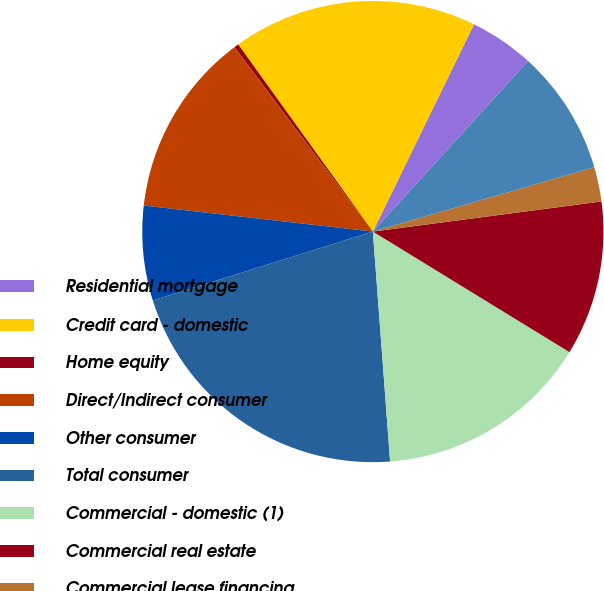Convert chart. <chart><loc_0><loc_0><loc_500><loc_500><pie_chart><fcel>Residential mortgage<fcel>Credit card - domestic<fcel>Home equity<fcel>Direct/Indirect consumer<fcel>Other consumer<fcel>Total consumer<fcel>Commercial - domestic (1)<fcel>Commercial real estate<fcel>Commercial lease financing<fcel>Commercial - foreign<nl><fcel>4.53%<fcel>17.15%<fcel>0.32%<fcel>12.95%<fcel>6.63%<fcel>21.36%<fcel>15.05%<fcel>10.84%<fcel>2.42%<fcel>8.74%<nl></chart> 